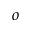<formula> <loc_0><loc_0><loc_500><loc_500>o</formula> 